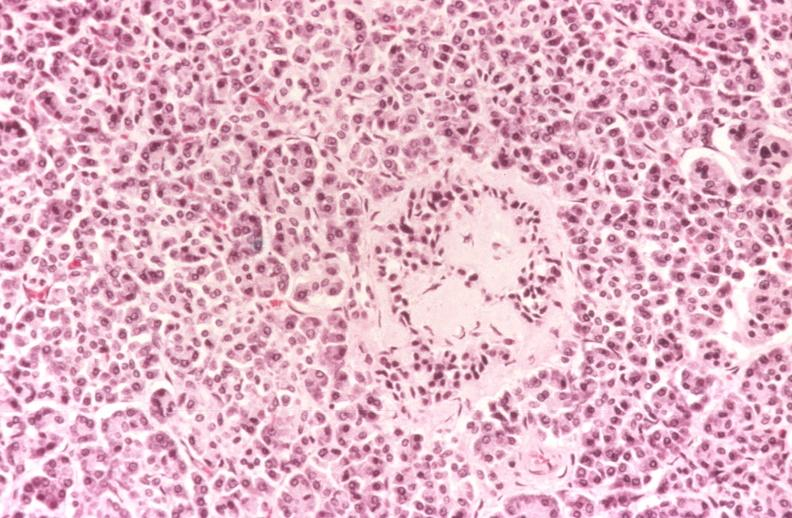what does this image show?
Answer the question using a single word or phrase. Kidney 